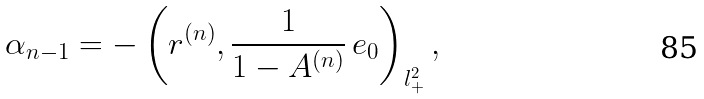<formula> <loc_0><loc_0><loc_500><loc_500>\alpha _ { n - 1 } = - \left ( r ^ { ( n ) } , \frac { 1 } { 1 - A ^ { ( n ) } } \, e _ { 0 } \right ) _ { l ^ { 2 } _ { + } } ,</formula> 